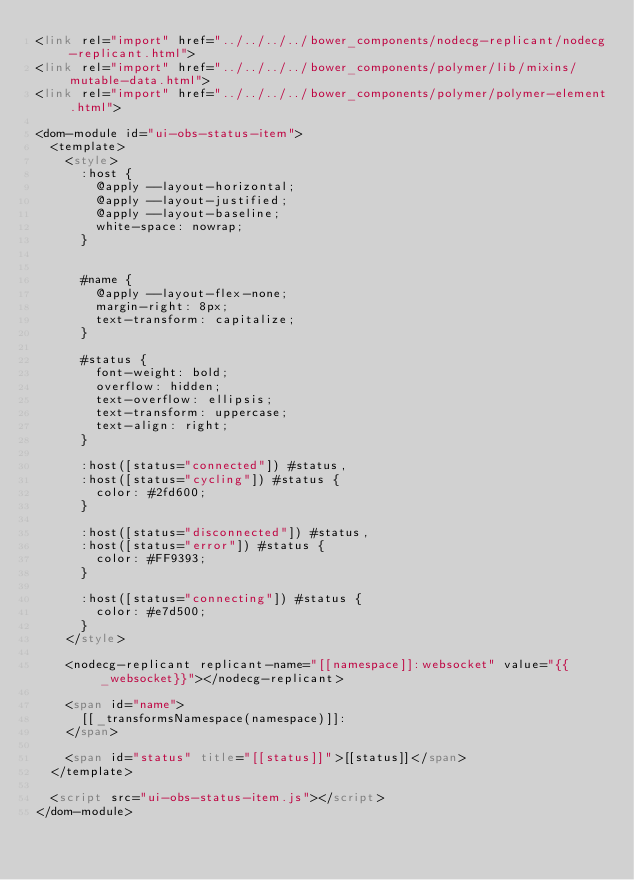Convert code to text. <code><loc_0><loc_0><loc_500><loc_500><_HTML_><link rel="import" href="../../../../bower_components/nodecg-replicant/nodecg-replicant.html">
<link rel="import" href="../../../../bower_components/polymer/lib/mixins/mutable-data.html">
<link rel="import" href="../../../../bower_components/polymer/polymer-element.html">

<dom-module id="ui-obs-status-item">
	<template>
		<style>
			:host {
				@apply --layout-horizontal;
				@apply --layout-justified;
				@apply --layout-baseline;
				white-space: nowrap;
			}


			#name {
				@apply --layout-flex-none;
				margin-right: 8px;
				text-transform: capitalize;
			}

			#status {
				font-weight: bold;
				overflow: hidden;
				text-overflow: ellipsis;
				text-transform: uppercase;
				text-align: right;
			}

			:host([status="connected"]) #status,
			:host([status="cycling"]) #status {
				color: #2fd600;
			}

			:host([status="disconnected"]) #status,
			:host([status="error"]) #status {
				color: #FF9393;
			}

			:host([status="connecting"]) #status {
				color: #e7d500;
			}
		</style>

		<nodecg-replicant replicant-name="[[namespace]]:websocket" value="{{_websocket}}"></nodecg-replicant>

		<span id="name">
			[[_transformsNamespace(namespace)]]:
		</span>

		<span id="status" title="[[status]]">[[status]]</span>
	</template>

	<script src="ui-obs-status-item.js"></script>
</dom-module>
</code> 